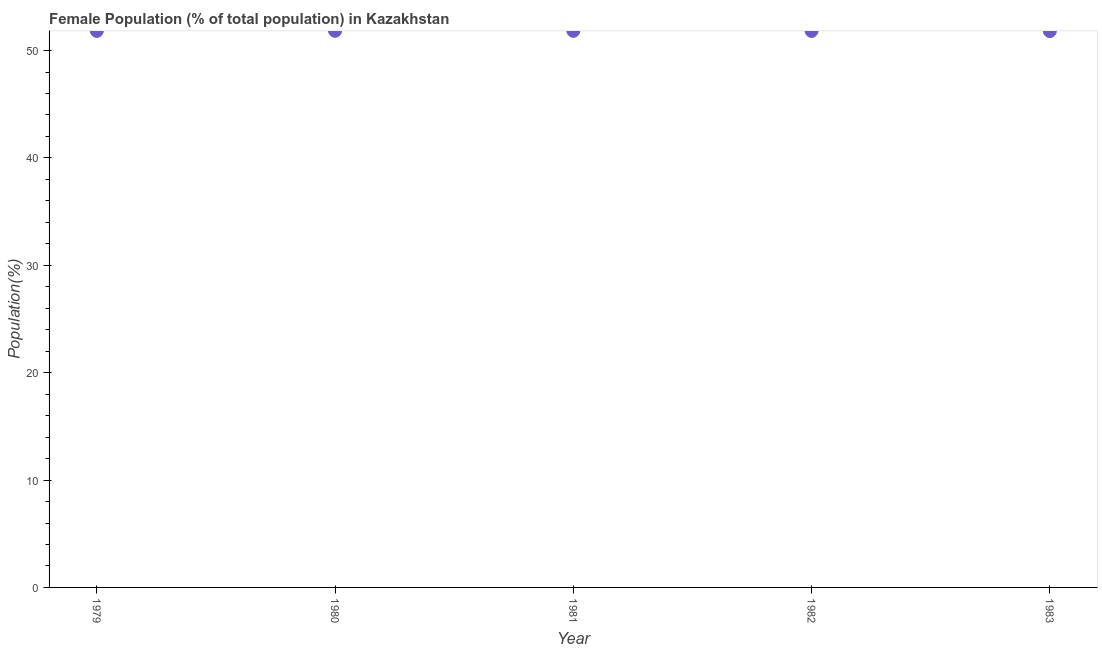What is the female population in 1983?
Keep it short and to the point. 51.81. Across all years, what is the maximum female population?
Provide a short and direct response. 51.84. Across all years, what is the minimum female population?
Your response must be concise. 51.81. In which year was the female population minimum?
Provide a succinct answer. 1983. What is the sum of the female population?
Your answer should be compact. 259.14. What is the difference between the female population in 1980 and 1983?
Offer a very short reply. 0.02. What is the average female population per year?
Offer a terse response. 51.83. What is the median female population?
Provide a short and direct response. 51.83. What is the ratio of the female population in 1979 to that in 1980?
Provide a short and direct response. 1. Is the female population in 1979 less than that in 1980?
Offer a terse response. Yes. Is the difference between the female population in 1981 and 1983 greater than the difference between any two years?
Your answer should be very brief. No. What is the difference between the highest and the second highest female population?
Ensure brevity in your answer.  0. What is the difference between the highest and the lowest female population?
Ensure brevity in your answer.  0.02. Does the graph contain any zero values?
Ensure brevity in your answer.  No. What is the title of the graph?
Give a very brief answer. Female Population (% of total population) in Kazakhstan. What is the label or title of the Y-axis?
Your response must be concise. Population(%). What is the Population(%) in 1979?
Your answer should be compact. 51.83. What is the Population(%) in 1980?
Your answer should be very brief. 51.84. What is the Population(%) in 1981?
Your response must be concise. 51.83. What is the Population(%) in 1982?
Provide a succinct answer. 51.83. What is the Population(%) in 1983?
Your answer should be compact. 51.81. What is the difference between the Population(%) in 1979 and 1980?
Your answer should be compact. -0.01. What is the difference between the Population(%) in 1979 and 1981?
Keep it short and to the point. -0. What is the difference between the Population(%) in 1979 and 1982?
Offer a terse response. 0. What is the difference between the Population(%) in 1979 and 1983?
Provide a succinct answer. 0.02. What is the difference between the Population(%) in 1980 and 1981?
Keep it short and to the point. 0. What is the difference between the Population(%) in 1980 and 1982?
Provide a short and direct response. 0.01. What is the difference between the Population(%) in 1980 and 1983?
Offer a very short reply. 0.02. What is the difference between the Population(%) in 1981 and 1982?
Ensure brevity in your answer.  0.01. What is the difference between the Population(%) in 1981 and 1983?
Offer a terse response. 0.02. What is the difference between the Population(%) in 1982 and 1983?
Give a very brief answer. 0.01. What is the ratio of the Population(%) in 1979 to that in 1981?
Your answer should be very brief. 1. What is the ratio of the Population(%) in 1980 to that in 1982?
Keep it short and to the point. 1. What is the ratio of the Population(%) in 1982 to that in 1983?
Your answer should be very brief. 1. 